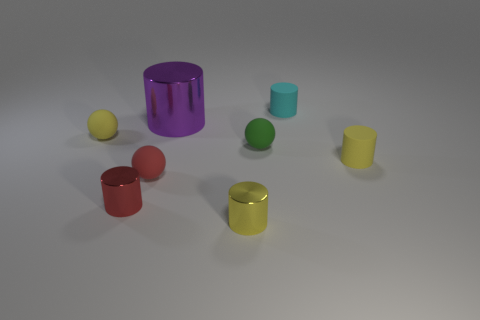Subtract all yellow matte cylinders. How many cylinders are left? 4 Add 1 red matte objects. How many objects exist? 9 Subtract all gray balls. How many yellow cylinders are left? 2 Subtract all green balls. How many balls are left? 2 Subtract 3 cylinders. How many cylinders are left? 2 Subtract all red cylinders. Subtract all blue cubes. How many cylinders are left? 4 Subtract all purple objects. Subtract all green objects. How many objects are left? 6 Add 6 small red things. How many small red things are left? 8 Add 2 purple metal cylinders. How many purple metal cylinders exist? 3 Subtract 0 purple cubes. How many objects are left? 8 